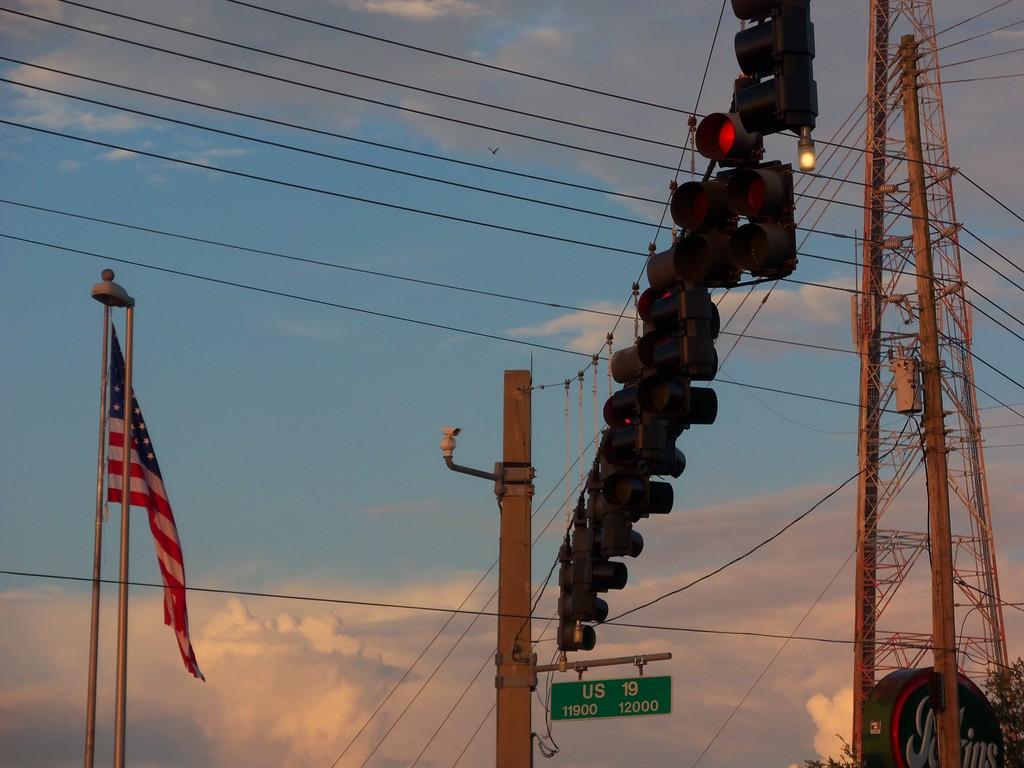What is the number on the bottom right side of the sign?
Your answer should be compact. 12000. 